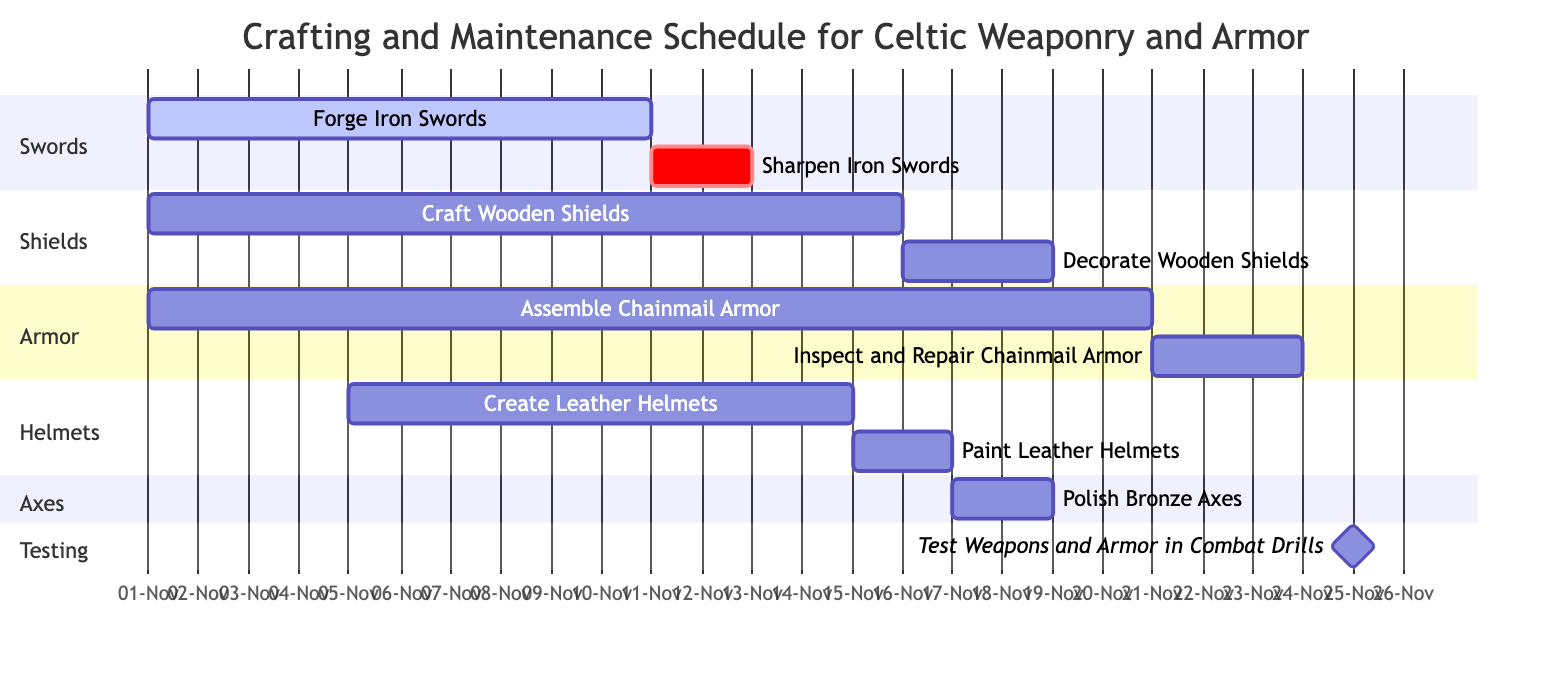What is the duration of the task "Forge Iron Swords"? The task "Forge Iron Swords" starts on November 1, 2023, and ends on November 10, 2023. The duration can be calculated by counting the days from the start date to the end date, which is 10 days.
Answer: 10 days When does the task "Decorate Wooden Shields" start? The task "Decorate Wooden Shields" is listed in the diagram and has a start date of November 16, 2023. This information is directly visible in the section labeled "Shields."
Answer: November 16, 2023 Which task comes after "Assemble Chainmail Armor"? The task that directly follows "Assemble Chainmail Armor" is "Inspect and Repair Chainmail Armor." This is indicated by the dependency line connecting the two tasks.
Answer: Inspect and Repair Chainmail Armor How many days are allocated to "Create Leather Helmets"? The task "Create Leather Helmets" starts on November 5, 2023, and ends on November 14, 2023. The duration is calculated by subtracting the start date from the end date, resulting in 10 days.
Answer: 10 days What tasks must be completed before testing the weapons and armor? The tasks that must be completed before testing are "Sharpen Iron Swords," "Decorate Wooden Shields," "Inspect and Repair Chainmail Armor," "Paint Leather Helmets," and "Polish Bronze Axes." All of these tasks have direct dependency connections to the testing task, indicating they must be finished first.
Answer: Sharpen Iron Swords, Decorate Wooden Shields, Inspect and Repair Chainmail Armor, Paint Leather Helmets, Polish Bronze Axes How many sections are there in the Gantt chart? The Gantt chart has five sections: Swords, Shields, Armor, Helmets, and Axes. Each section represents a category of tasks related to weaponry and armor crafting.
Answer: 5 sections What is the earliest task scheduled in the chart? The earliest task in the chart is "Forge Iron Swords," which starts on November 1, 2023. This is determined by reviewing the start dates of all tasks.
Answer: Forge Iron Swords How long does the task "Inspect and Repair Chainmail Armor" last? The task "Inspect and Repair Chainmail Armor" starts on November 21, 2023, and ends on November 23, 2023. Thus, the duration is 3 days, calculated by the difference between the two dates.
Answer: 3 days What is the last task that will be done before the combat drills? The last task completed before the combat drills is "Paint Leather Helmets," which ends on November 16, 2023. The combat drills begin on November 24, 2023, so this is the most recent task that must be finished beforehand.
Answer: Paint Leather Helmets 